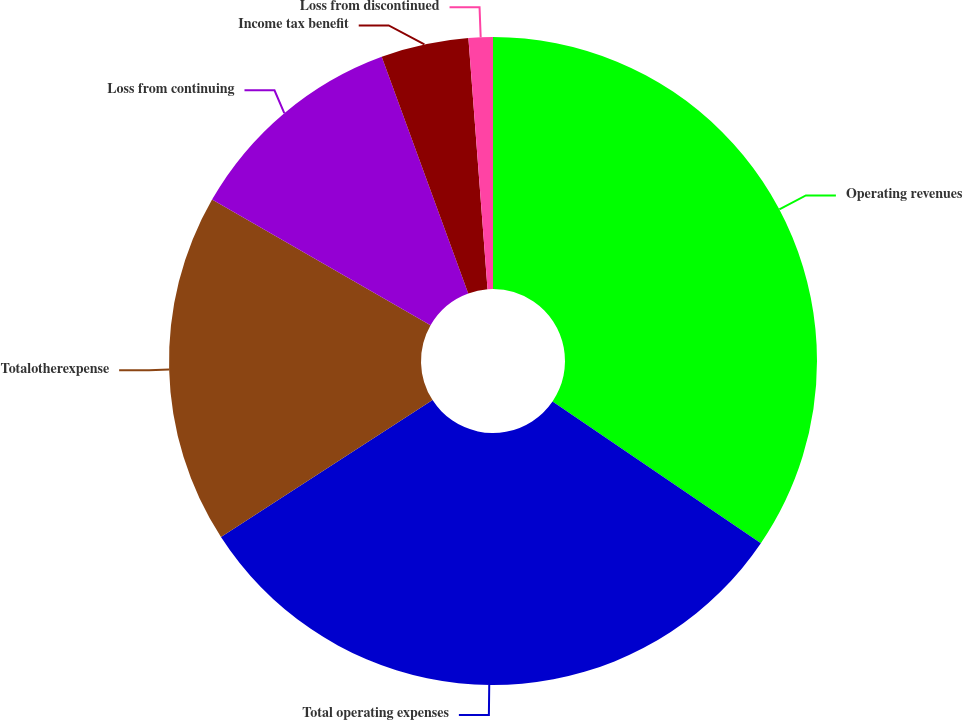Convert chart. <chart><loc_0><loc_0><loc_500><loc_500><pie_chart><fcel>Operating revenues<fcel>Total operating expenses<fcel>Totalotherexpense<fcel>Loss from continuing<fcel>Income tax benefit<fcel>Loss from discontinued<nl><fcel>34.51%<fcel>31.35%<fcel>17.44%<fcel>11.12%<fcel>4.37%<fcel>1.21%<nl></chart> 